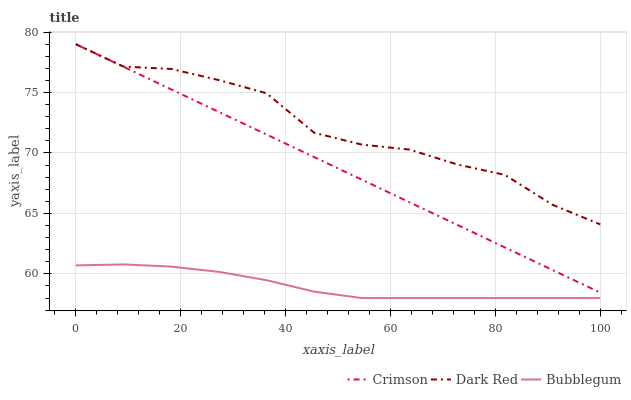Does Bubblegum have the minimum area under the curve?
Answer yes or no. Yes. Does Dark Red have the maximum area under the curve?
Answer yes or no. Yes. Does Dark Red have the minimum area under the curve?
Answer yes or no. No. Does Bubblegum have the maximum area under the curve?
Answer yes or no. No. Is Crimson the smoothest?
Answer yes or no. Yes. Is Dark Red the roughest?
Answer yes or no. Yes. Is Bubblegum the smoothest?
Answer yes or no. No. Is Bubblegum the roughest?
Answer yes or no. No. Does Dark Red have the lowest value?
Answer yes or no. No. Does Dark Red have the highest value?
Answer yes or no. Yes. Does Bubblegum have the highest value?
Answer yes or no. No. Is Bubblegum less than Dark Red?
Answer yes or no. Yes. Is Crimson greater than Bubblegum?
Answer yes or no. Yes. Does Bubblegum intersect Dark Red?
Answer yes or no. No. 